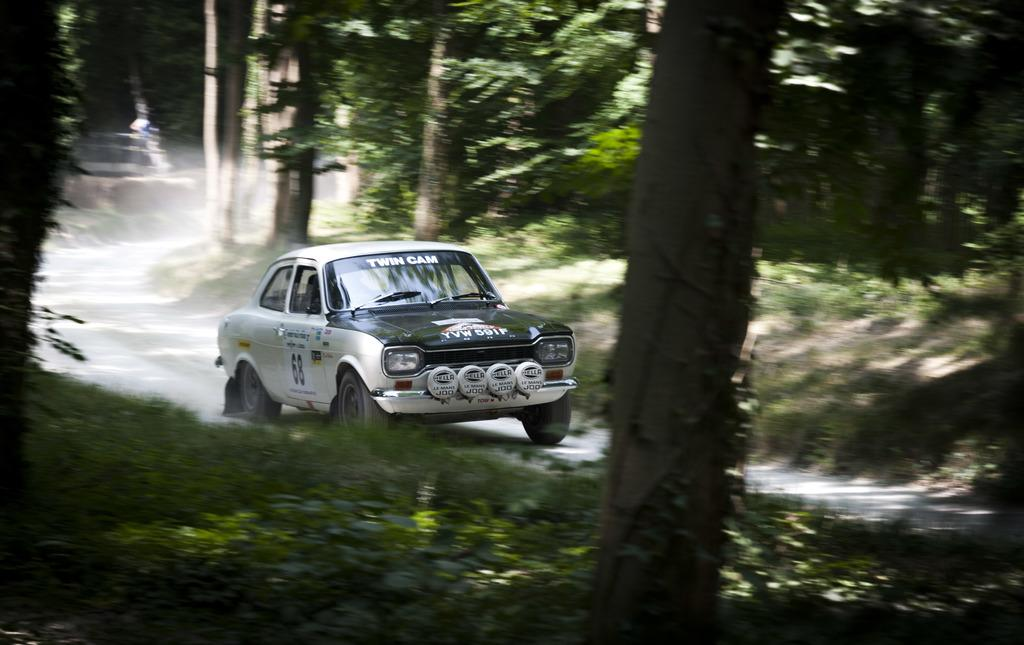What is the main subject of the image? The main subject of the image is a car on the road. What can be seen in the background of the image? There is a bark of a tree and plants in the image. What type of vegetation is visible in the image? There are trees in the image. Can you tell me how many basketballs are lying on the ground near the car in the image? There are no basketballs present in the image. Is the grandfather sitting on the car in the image? There is no grandfather present in the image. --- Facts: 1. There is a person holding a book in the image. 2. The person is sitting on a chair. 3. There is a table in the image. 4. There is a lamp on the table. Absurd Topics: parrot, bicycle, ocean Conversation: What is the person in the image holding? The person in the image is holding a book. What is the person's position in the image? The person is sitting on a chair. What other piece of furniture is visible in the image? There is a table in the image. What object is on the table in the image? There is a lamp on the table. Reasoning: Let's think step by step in order to produce the conversation. We start by identifying the main subject of the image, which is the person holding a book. Then, we describe the person's position in the image, which is sitting on a chair. Next, we mention the presence of a table in the image. Finally, we identify the object on the table, which is a lamp. Absurd Question/Answer: Can you tell me how many parrots are sitting on the bicycle in the image? There are no parrots or bicycles present in the image. Is the ocean visible in the background of the image? There is no ocean visible in the image. --- Facts: 1. There is a person standing near a fence in the image. 2. The person is holding a camera. 3. There is a field in the background of the image. 4. There are clouds in the sky. Absurd Topics: elephant, piano, volcano Conversation: What is the person in the image doing? The person in the image is standing near a fence and holding a camera. What might the person be about to do? The person might be about to take a picture, given that they are holding a camera. What can be seen in the background of the image? There is a field in the background of the image. What is visible in the sky in the image? There are clouds in the sky. Reasoning: Let's think step by step in order to produce the conversation. We start by identifying the main subject of the image, which is the person standing near a fence and holding a camera. Then, we describe the 